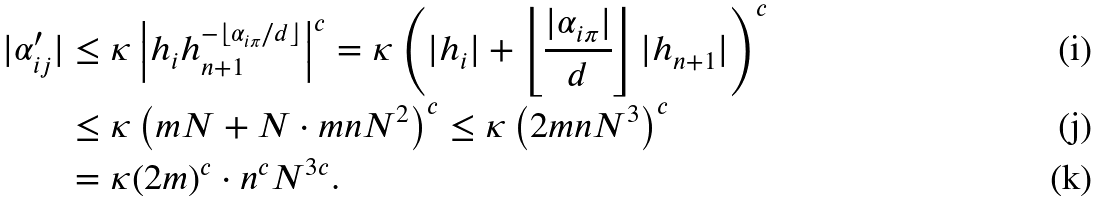Convert formula to latex. <formula><loc_0><loc_0><loc_500><loc_500>| \alpha _ { i j } ^ { \prime } | & \leq \kappa \left | h _ { i } h _ { n + 1 } ^ { - \lfloor \alpha _ { i \pi } / d \rfloor } \right | ^ { c } = \kappa \left ( | h _ { i } | + \left \lfloor \frac { | \alpha _ { i \pi } | } { d } \right \rfloor | h _ { n + 1 } | \right ) ^ { c } \\ & \leq \kappa \left ( m N + N \cdot m n N ^ { 2 } \right ) ^ { c } \leq \kappa \left ( 2 m n N ^ { 3 } \right ) ^ { c } \\ & = \kappa ( 2 m ) ^ { c } \cdot n ^ { c } N ^ { 3 c } .</formula> 